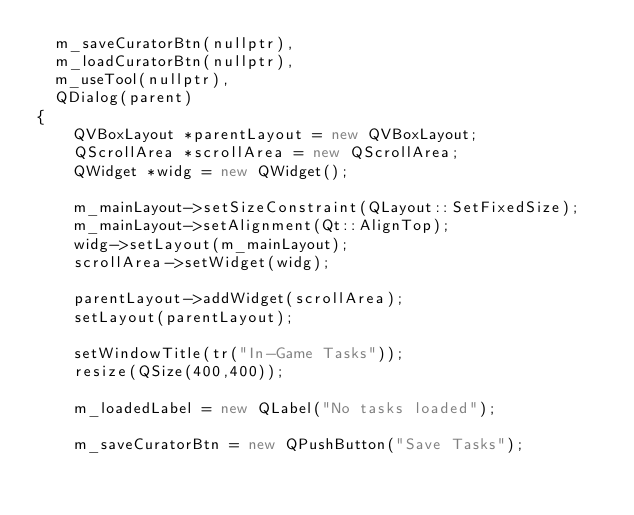Convert code to text. <code><loc_0><loc_0><loc_500><loc_500><_C++_>  m_saveCuratorBtn(nullptr),
  m_loadCuratorBtn(nullptr),
  m_useTool(nullptr),
  QDialog(parent)
{
    QVBoxLayout *parentLayout = new QVBoxLayout;
    QScrollArea *scrollArea = new QScrollArea;
    QWidget *widg = new QWidget();

    m_mainLayout->setSizeConstraint(QLayout::SetFixedSize);
    m_mainLayout->setAlignment(Qt::AlignTop);
    widg->setLayout(m_mainLayout);
    scrollArea->setWidget(widg);

    parentLayout->addWidget(scrollArea);
    setLayout(parentLayout);

    setWindowTitle(tr("In-Game Tasks"));
    resize(QSize(400,400));

    m_loadedLabel = new QLabel("No tasks loaded");

    m_saveCuratorBtn = new QPushButton("Save Tasks");</code> 